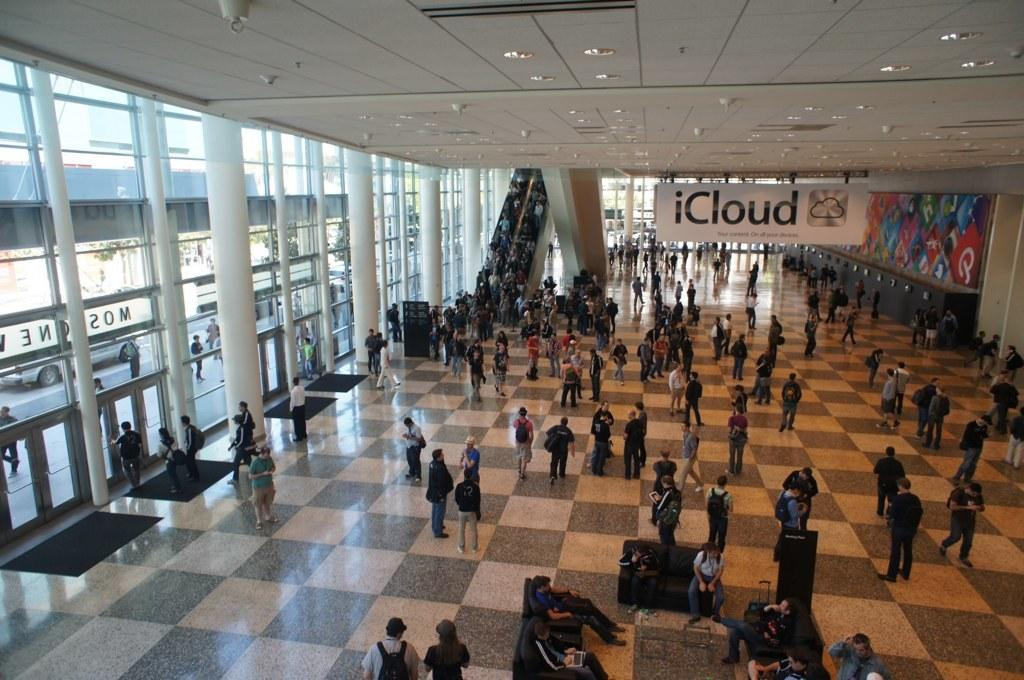How many persons can be seen in the image? There are persons in the image. What type of transportation feature is present in the image? There is an escalator in the image. What architectural elements can be seen in the image? There are windows and doors in the image. What type of vehicles are visible in the image? There are cars in the image. What is the outdoor environment like in the image? There is a road and trees in the image. What additional object can be seen in the image? There is a board in the image. What type of furniture is present in the image? There is a sofa set in the image. What type of property is being discussed in the image? There is no discussion of property in the image. What type of punishment is being administered in the image? There is no punishment being administered in the image. What type of acoustics can be heard in the image? There is no audio or sound present in the image, so it is not possible to determine the acoustics. 